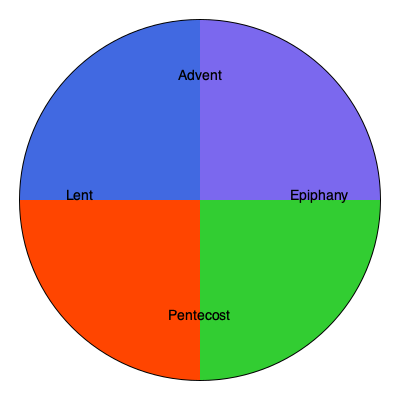Which liturgical season in the Episcopal Church calendar is represented by the green section in the circular graphic? To answer this question, let's analyze the circular graphic representing the Episcopal Church's liturgical calendar:

1. The circle is divided into four sections, each representing a different liturgical season.

2. The colors used in the Episcopal Church calendar typically have specific meanings:
   - Purple (or blue) represents Advent
   - White or Gold represents Christmas and Epiphany
   - Purple represents Lent
   - Red represents Holy Week and Pentecost
   - Green represents Ordinary Time (also called the Season after Epiphany and the Season after Pentecost)

3. In this graphic, we can identify:
   - Blue section (top right): labeled as Advent
   - Green section (bottom right): labeled as Epiphany
   - Orange/Red section (bottom left): labeled as Pentecost
   - Blue section (top left): labeled as Lent

4. The question asks specifically about the green section.

5. In the Episcopal Church calendar, the green color is associated with Ordinary Time, which includes both the Season after Epiphany and the Season after Pentecost.

6. In this graphic, the green section is labeled as "Epiphany," which refers to the Season after Epiphany.

Therefore, the green section in the circular graphic represents the Season after Epiphany in the Episcopal Church liturgical calendar.
Answer: Season after Epiphany 